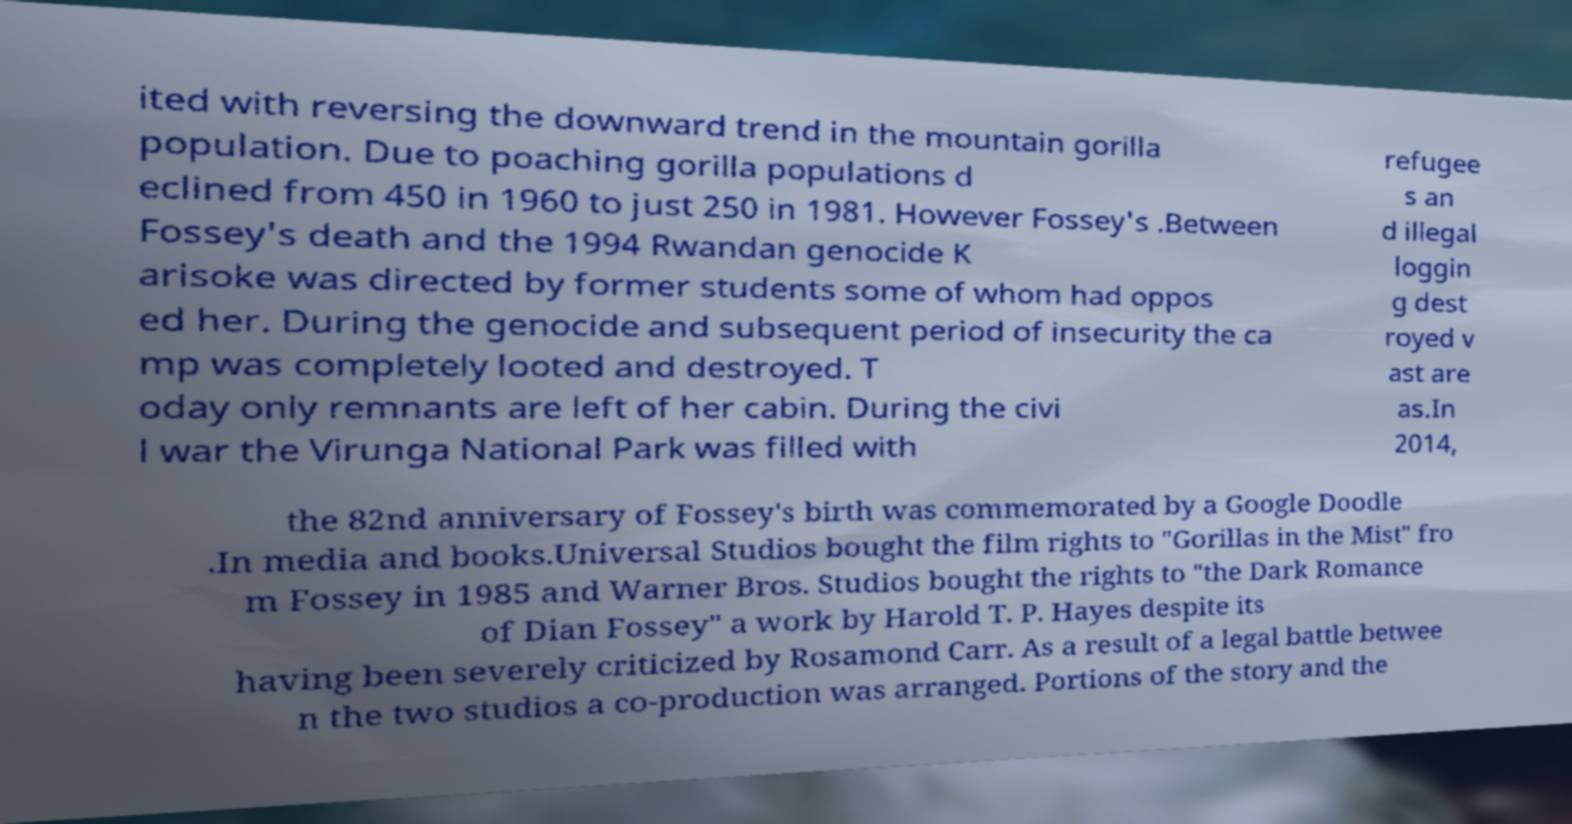Can you accurately transcribe the text from the provided image for me? ited with reversing the downward trend in the mountain gorilla population. Due to poaching gorilla populations d eclined from 450 in 1960 to just 250 in 1981. However Fossey's .Between Fossey's death and the 1994 Rwandan genocide K arisoke was directed by former students some of whom had oppos ed her. During the genocide and subsequent period of insecurity the ca mp was completely looted and destroyed. T oday only remnants are left of her cabin. During the civi l war the Virunga National Park was filled with refugee s an d illegal loggin g dest royed v ast are as.In 2014, the 82nd anniversary of Fossey's birth was commemorated by a Google Doodle .In media and books.Universal Studios bought the film rights to "Gorillas in the Mist" fro m Fossey in 1985 and Warner Bros. Studios bought the rights to "the Dark Romance of Dian Fossey" a work by Harold T. P. Hayes despite its having been severely criticized by Rosamond Carr. As a result of a legal battle betwee n the two studios a co-production was arranged. Portions of the story and the 